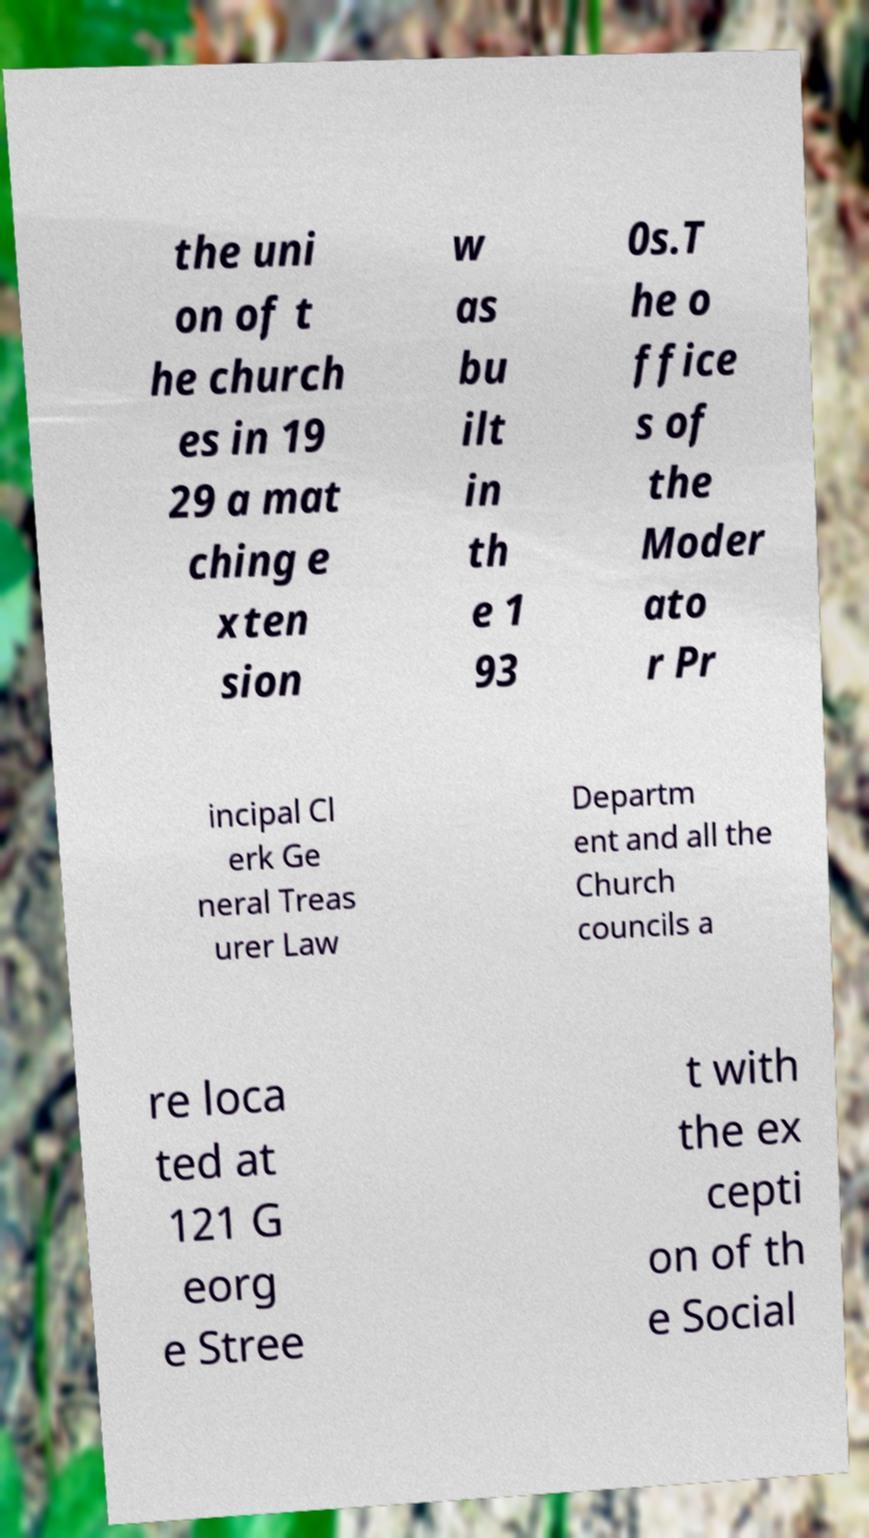Could you extract and type out the text from this image? the uni on of t he church es in 19 29 a mat ching e xten sion w as bu ilt in th e 1 93 0s.T he o ffice s of the Moder ato r Pr incipal Cl erk Ge neral Treas urer Law Departm ent and all the Church councils a re loca ted at 121 G eorg e Stree t with the ex cepti on of th e Social 